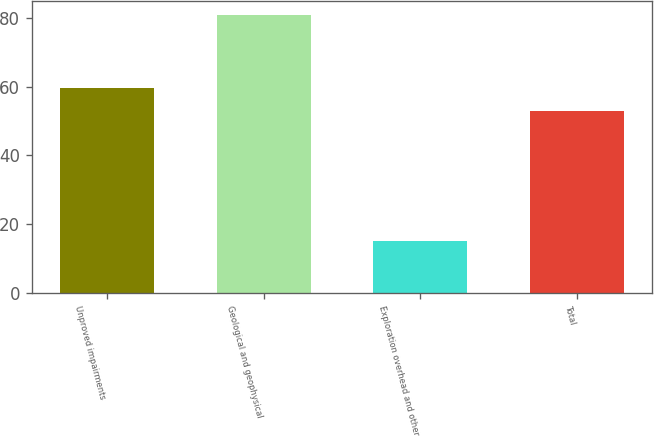Convert chart to OTSL. <chart><loc_0><loc_0><loc_500><loc_500><bar_chart><fcel>Unproved impairments<fcel>Geological and geophysical<fcel>Exploration overhead and other<fcel>Total<nl><fcel>59.6<fcel>81<fcel>15<fcel>53<nl></chart> 